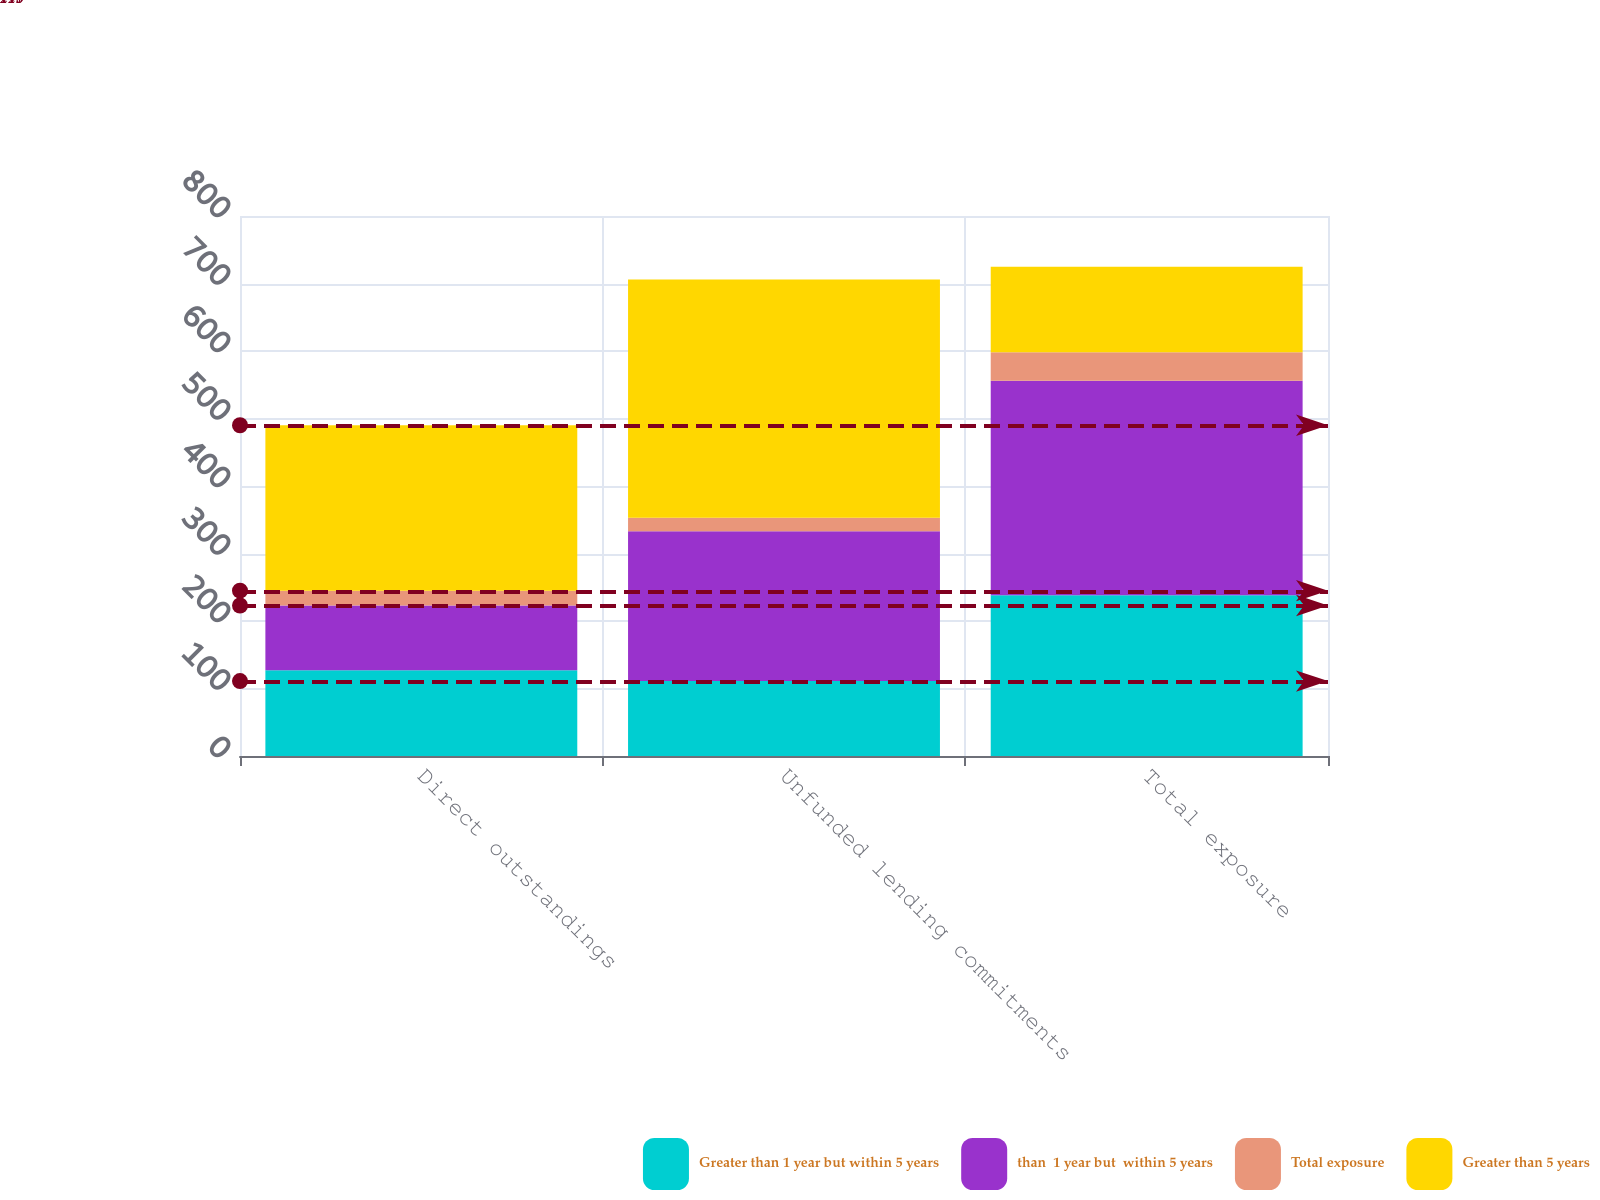Convert chart. <chart><loc_0><loc_0><loc_500><loc_500><stacked_bar_chart><ecel><fcel>Direct outstandings<fcel>Unfunded lending commitments<fcel>Total exposure<nl><fcel>Greater than 1 year but within 5 years<fcel>127<fcel>111<fcel>238<nl><fcel>than  1 year but  within 5 years<fcel>96<fcel>222<fcel>318<nl><fcel>Total exposure<fcel>22<fcel>20<fcel>42<nl><fcel>Greater than 5 years<fcel>245<fcel>353<fcel>127<nl></chart> 